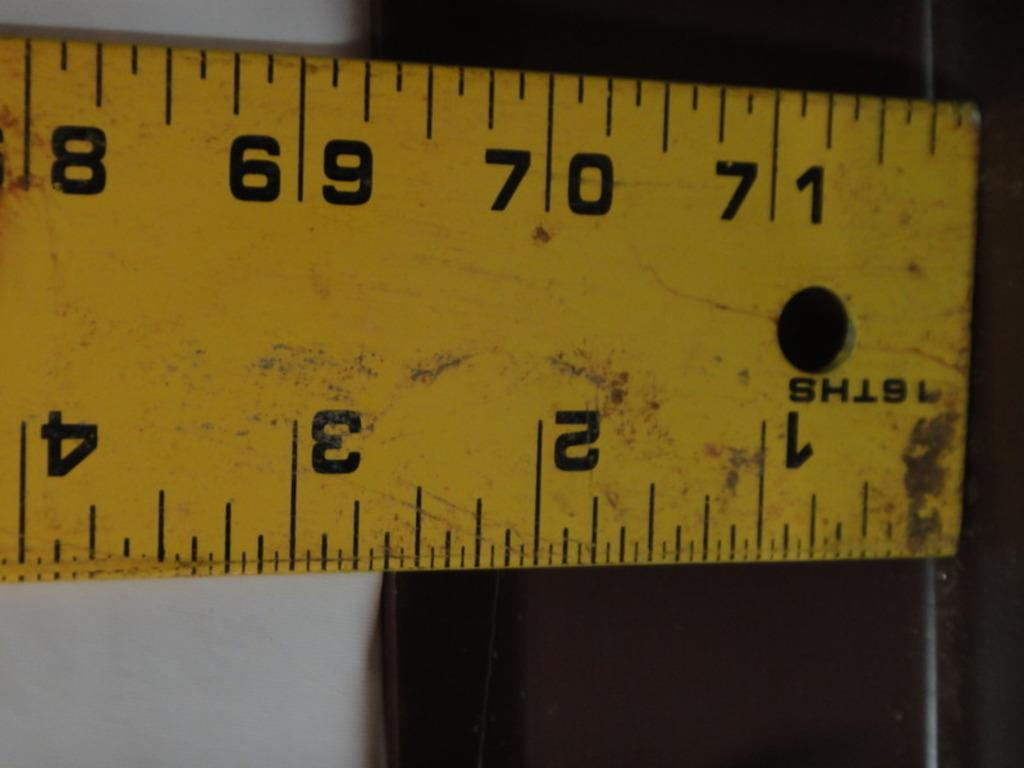Provide a one-sentence caption for the provided image. A tape measure starts at 1/16th and goes all the way up to 71 1/2. 